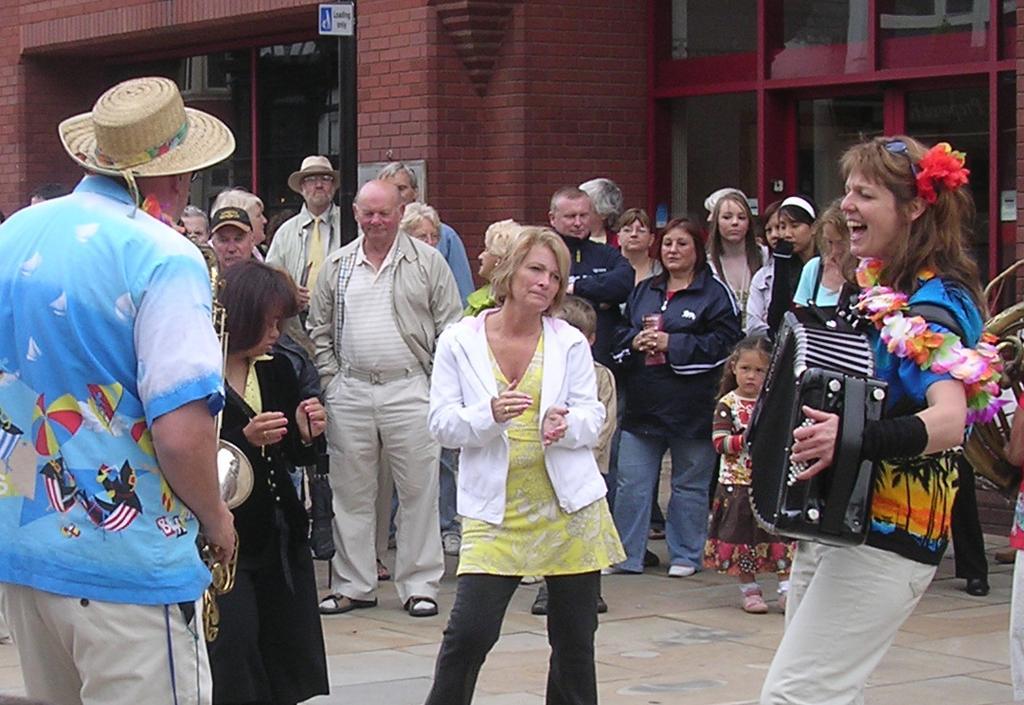Please provide a concise description of this image. In this picture there are people standing. The woman to the right corner is playing accordion. The man to the left corner is playing trumpet. The woman in the center is dancing. Behind her there is crowd and a building. 